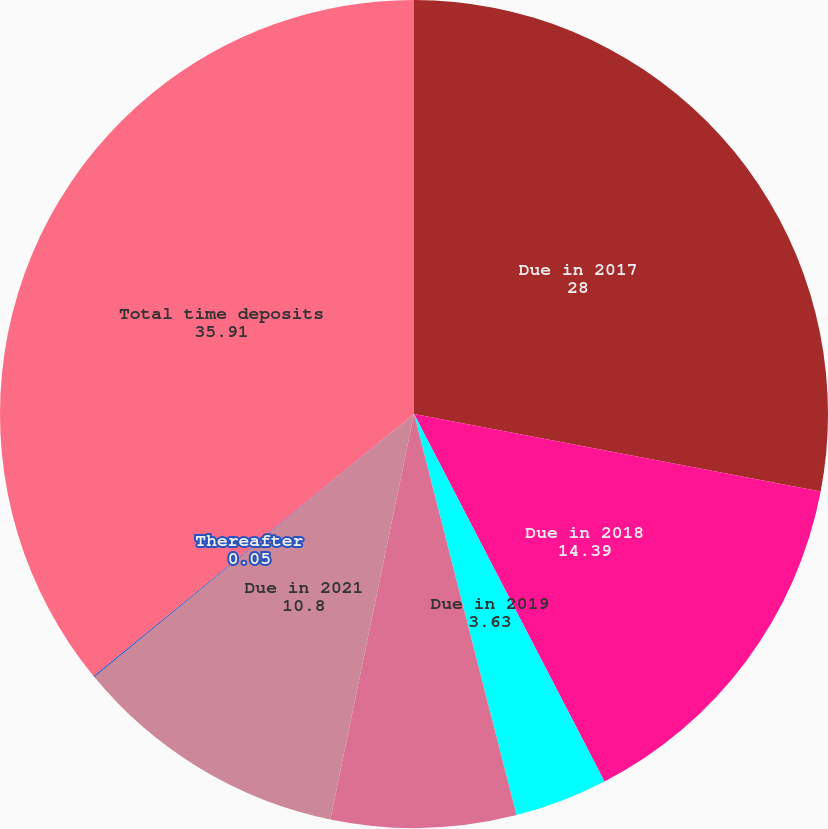Convert chart. <chart><loc_0><loc_0><loc_500><loc_500><pie_chart><fcel>Due in 2017<fcel>Due in 2018<fcel>Due in 2019<fcel>Due in 2020<fcel>Due in 2021<fcel>Thereafter<fcel>Total time deposits<nl><fcel>28.0%<fcel>14.39%<fcel>3.63%<fcel>7.22%<fcel>10.8%<fcel>0.05%<fcel>35.91%<nl></chart> 